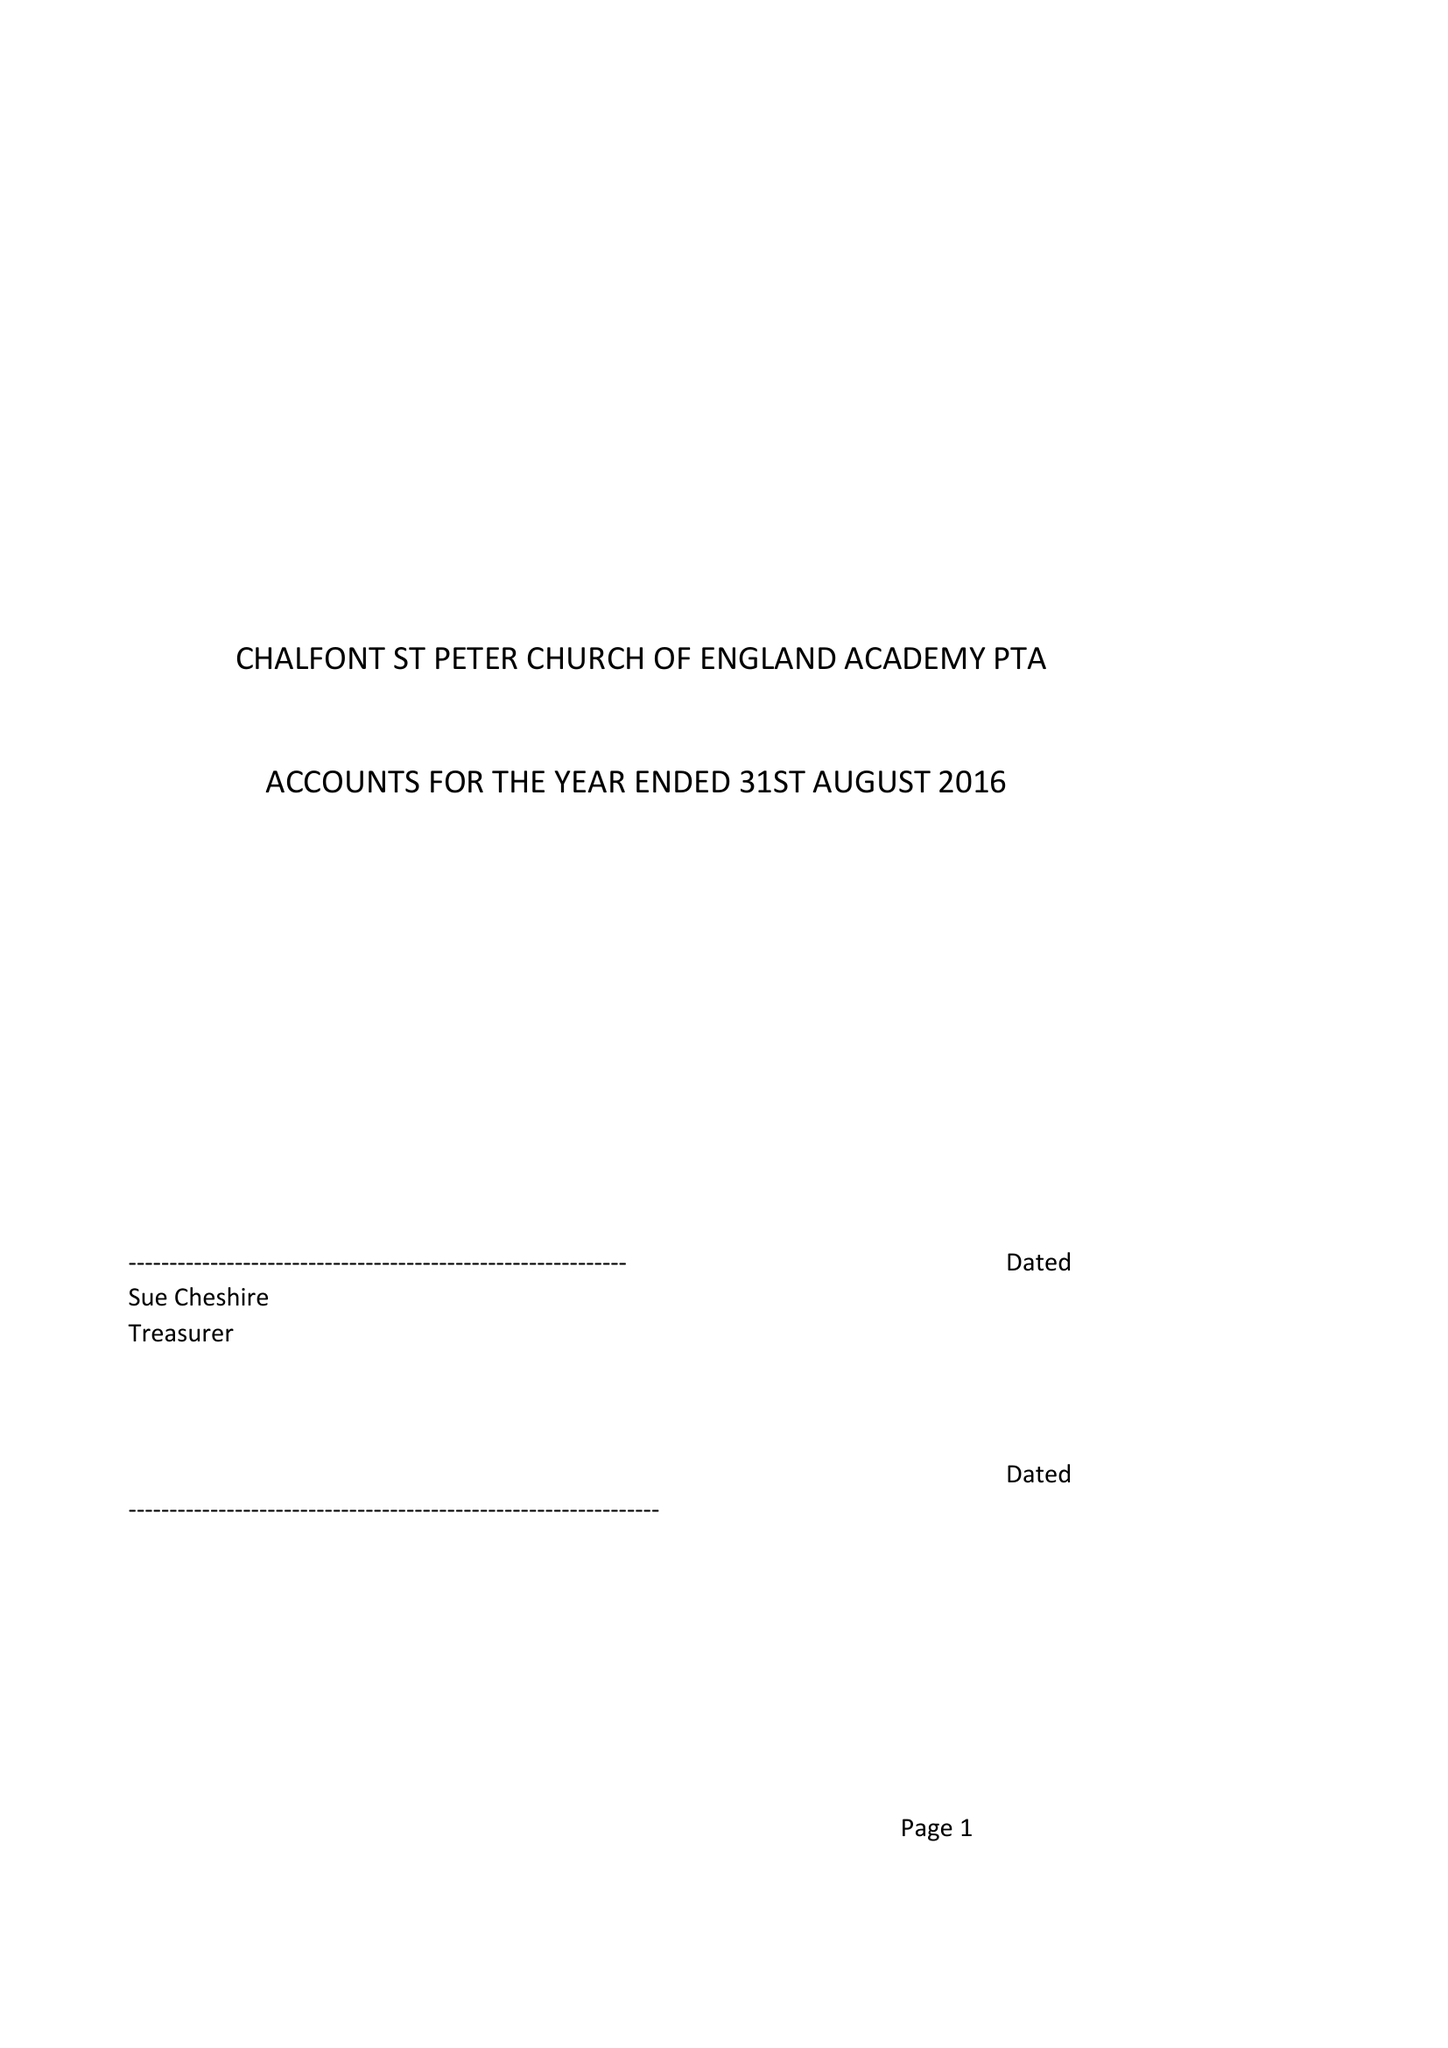What is the value for the spending_annually_in_british_pounds?
Answer the question using a single word or phrase. 43997.00 